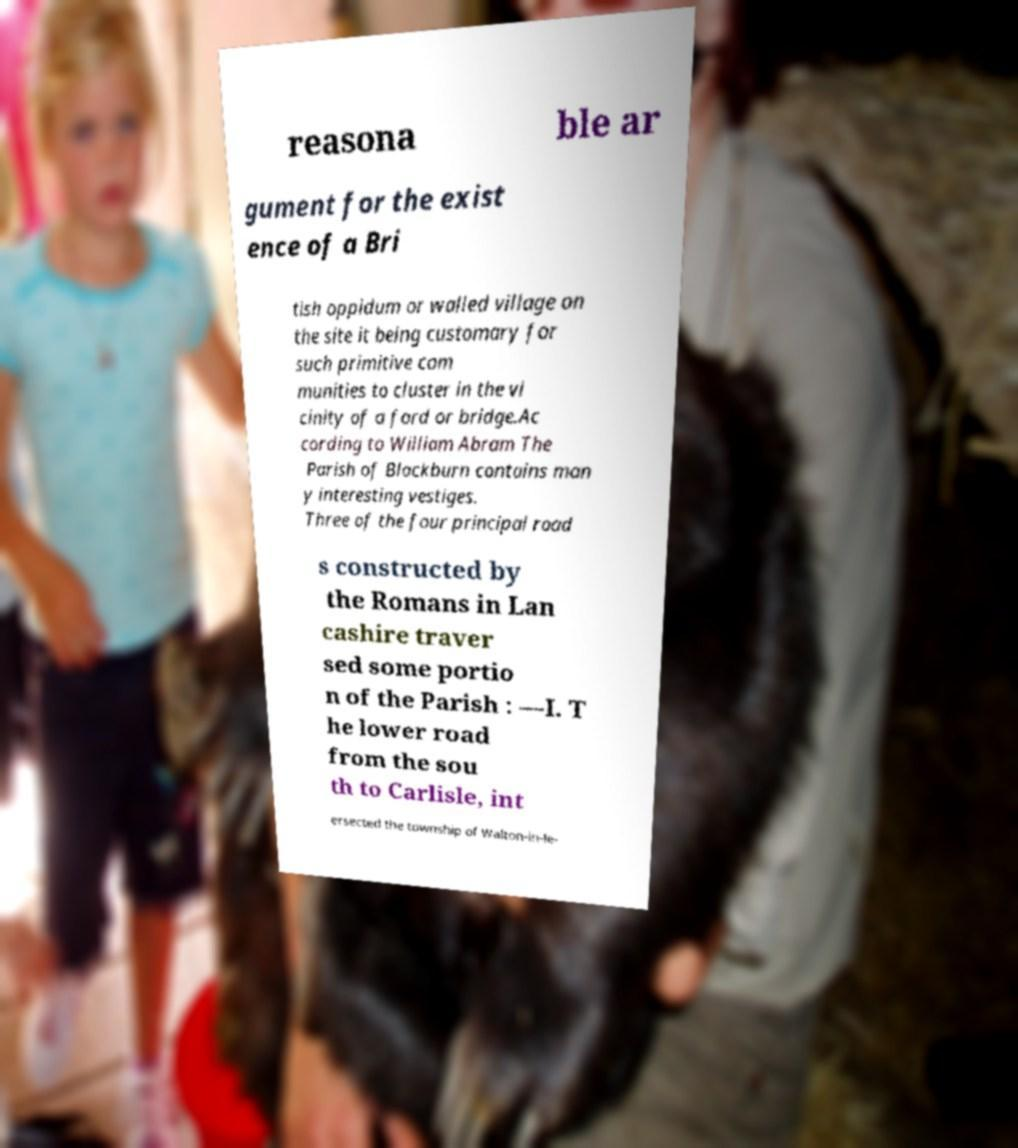What messages or text are displayed in this image? I need them in a readable, typed format. reasona ble ar gument for the exist ence of a Bri tish oppidum or walled village on the site it being customary for such primitive com munities to cluster in the vi cinity of a ford or bridge.Ac cording to William Abram The Parish of Blackburn contains man y interesting vestiges. Three of the four principal road s constructed by the Romans in Lan cashire traver sed some portio n of the Parish : —I. T he lower road from the sou th to Carlisle, int ersected the township of Walton-in-le- 